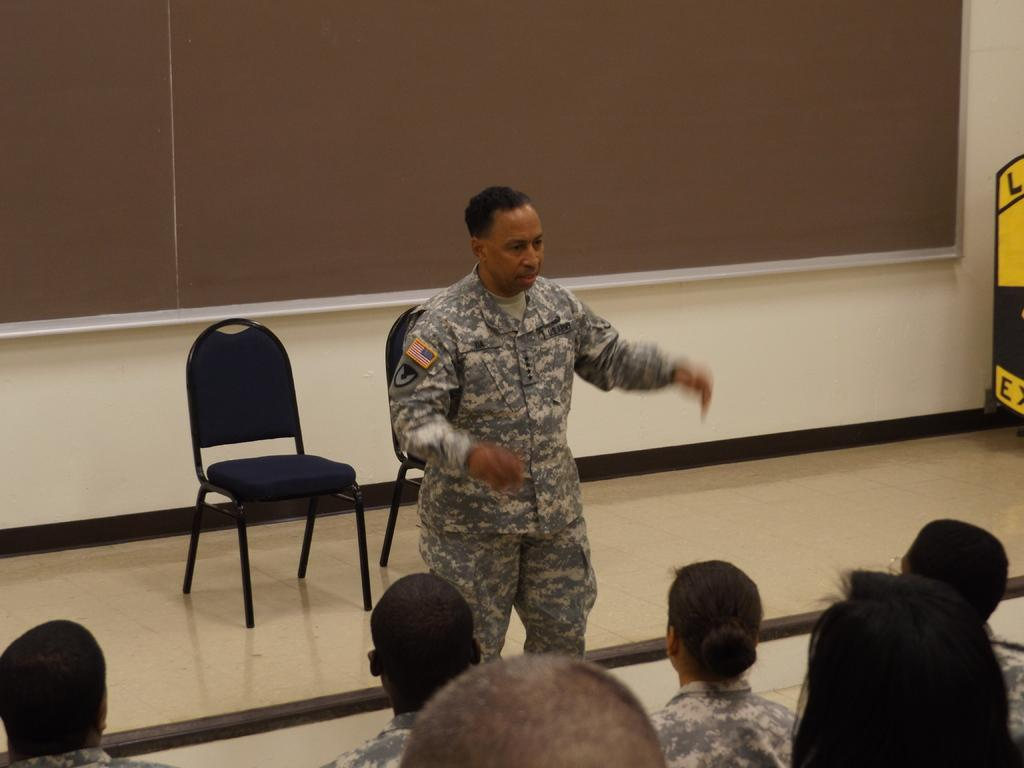What is the person in the image doing? The person is standing and speaking. Who is the speaker addressing in the image? There is a group of people in front of the speaker. What is the seating arrangement behind the speaker? There are two chairs behind the speaker. What type of nest can be seen in the image? There is no nest present in the image. How many potatoes are visible in the image? There are no potatoes present in the image. 